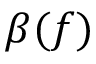<formula> <loc_0><loc_0><loc_500><loc_500>\beta ( f )</formula> 